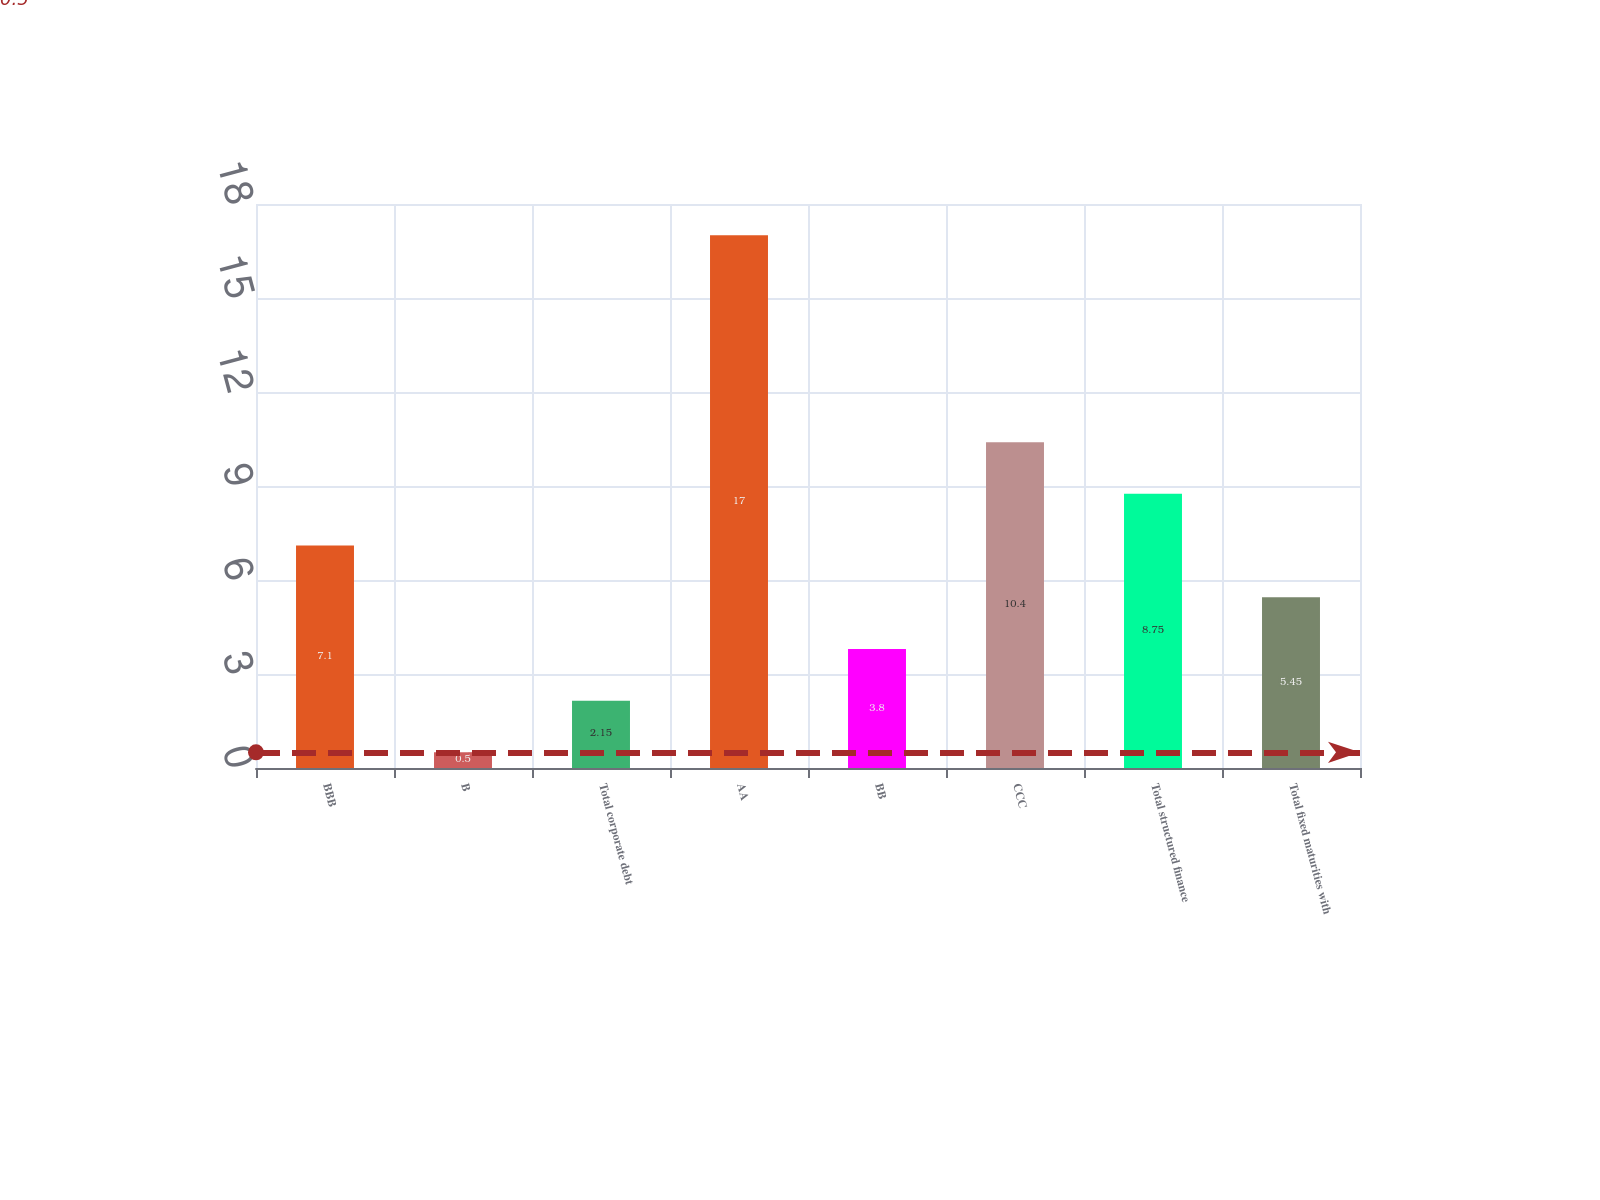Convert chart to OTSL. <chart><loc_0><loc_0><loc_500><loc_500><bar_chart><fcel>BBB<fcel>B<fcel>Total corporate debt<fcel>AA<fcel>BB<fcel>CCC<fcel>Total structured finance<fcel>Total fixed maturities with<nl><fcel>7.1<fcel>0.5<fcel>2.15<fcel>17<fcel>3.8<fcel>10.4<fcel>8.75<fcel>5.45<nl></chart> 